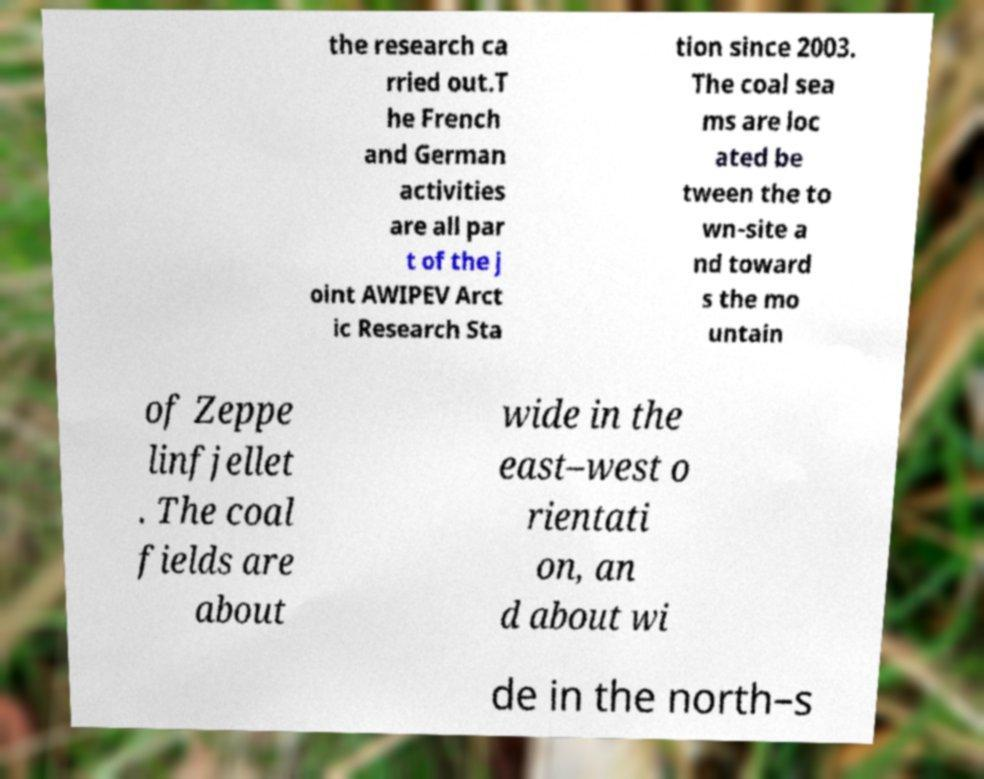Please identify and transcribe the text found in this image. the research ca rried out.T he French and German activities are all par t of the j oint AWIPEV Arct ic Research Sta tion since 2003. The coal sea ms are loc ated be tween the to wn-site a nd toward s the mo untain of Zeppe linfjellet . The coal fields are about wide in the east–west o rientati on, an d about wi de in the north–s 